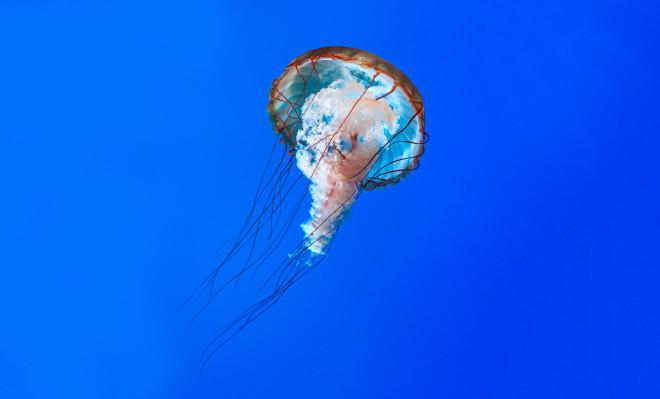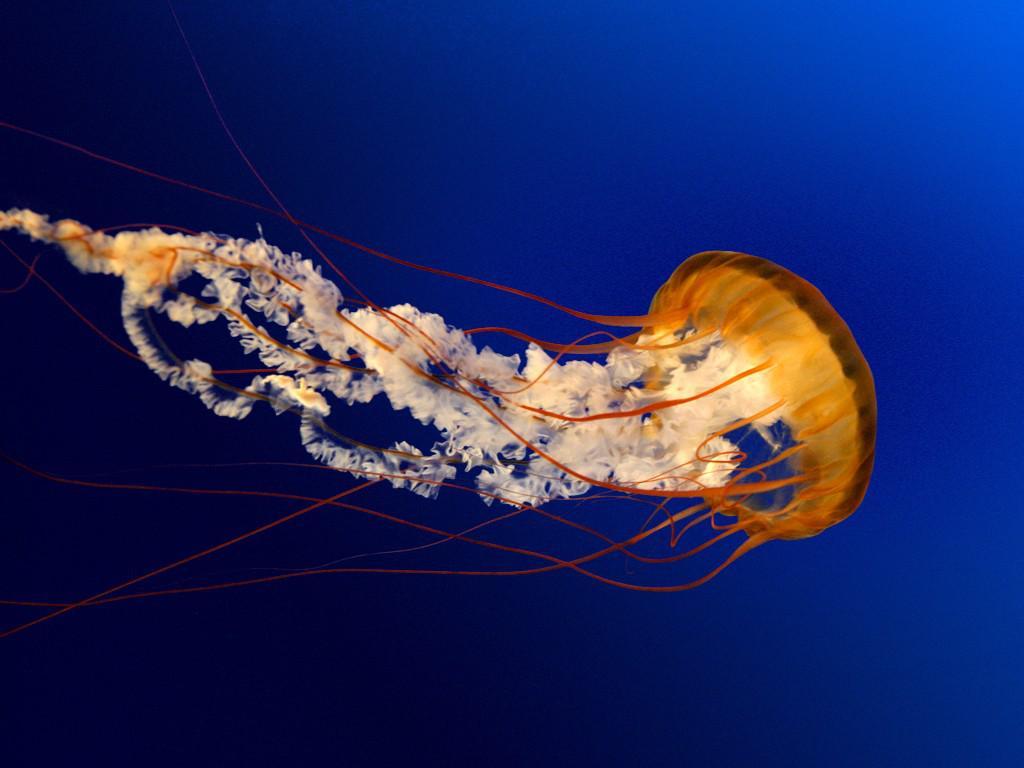The first image is the image on the left, the second image is the image on the right. For the images shown, is this caption "Exactly two orange jellyfish are swimming through the water, one of them toward the right and the other one toward the left." true? Answer yes or no. No. The first image is the image on the left, the second image is the image on the right. Assess this claim about the two images: "in the image pair the jelly fish are facing each other". Correct or not? Answer yes or no. No. 